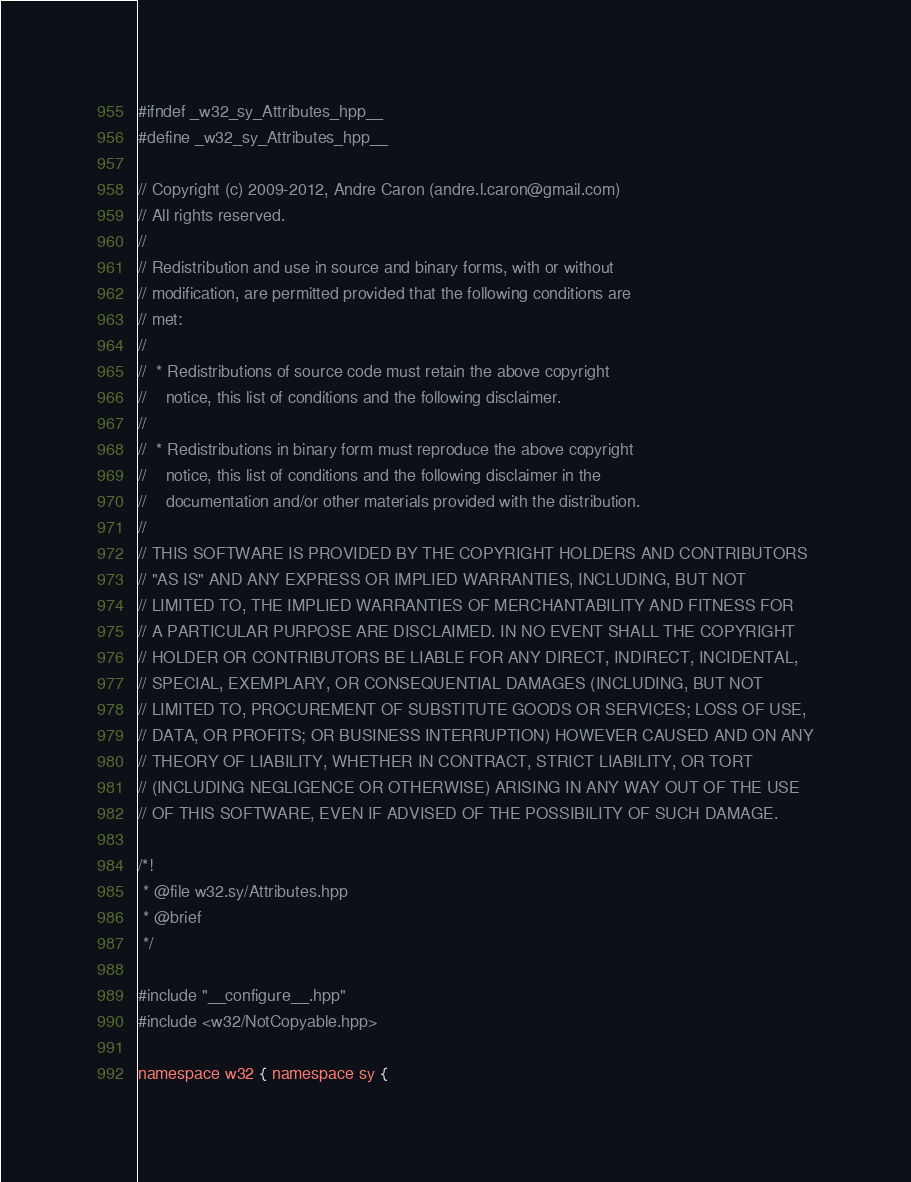Convert code to text. <code><loc_0><loc_0><loc_500><loc_500><_C++_>#ifndef _w32_sy_Attributes_hpp__
#define _w32_sy_Attributes_hpp__

// Copyright (c) 2009-2012, Andre Caron (andre.l.caron@gmail.com)
// All rights reserved.
// 
// Redistribution and use in source and binary forms, with or without
// modification, are permitted provided that the following conditions are
// met:
//
//  * Redistributions of source code must retain the above copyright
//    notice, this list of conditions and the following disclaimer.
//
//  * Redistributions in binary form must reproduce the above copyright
//    notice, this list of conditions and the following disclaimer in the
//    documentation and/or other materials provided with the distribution.
//
// THIS SOFTWARE IS PROVIDED BY THE COPYRIGHT HOLDERS AND CONTRIBUTORS
// "AS IS" AND ANY EXPRESS OR IMPLIED WARRANTIES, INCLUDING, BUT NOT
// LIMITED TO, THE IMPLIED WARRANTIES OF MERCHANTABILITY AND FITNESS FOR
// A PARTICULAR PURPOSE ARE DISCLAIMED. IN NO EVENT SHALL THE COPYRIGHT
// HOLDER OR CONTRIBUTORS BE LIABLE FOR ANY DIRECT, INDIRECT, INCIDENTAL,
// SPECIAL, EXEMPLARY, OR CONSEQUENTIAL DAMAGES (INCLUDING, BUT NOT
// LIMITED TO, PROCUREMENT OF SUBSTITUTE GOODS OR SERVICES; LOSS OF USE,
// DATA, OR PROFITS; OR BUSINESS INTERRUPTION) HOWEVER CAUSED AND ON ANY
// THEORY OF LIABILITY, WHETHER IN CONTRACT, STRICT LIABILITY, OR TORT
// (INCLUDING NEGLIGENCE OR OTHERWISE) ARISING IN ANY WAY OUT OF THE USE
// OF THIS SOFTWARE, EVEN IF ADVISED OF THE POSSIBILITY OF SUCH DAMAGE.

/*!
 * @file w32.sy/Attributes.hpp
 * @brief
 */

#include "__configure__.hpp"
#include <w32/NotCopyable.hpp>

namespace w32 { namespace sy {
</code> 